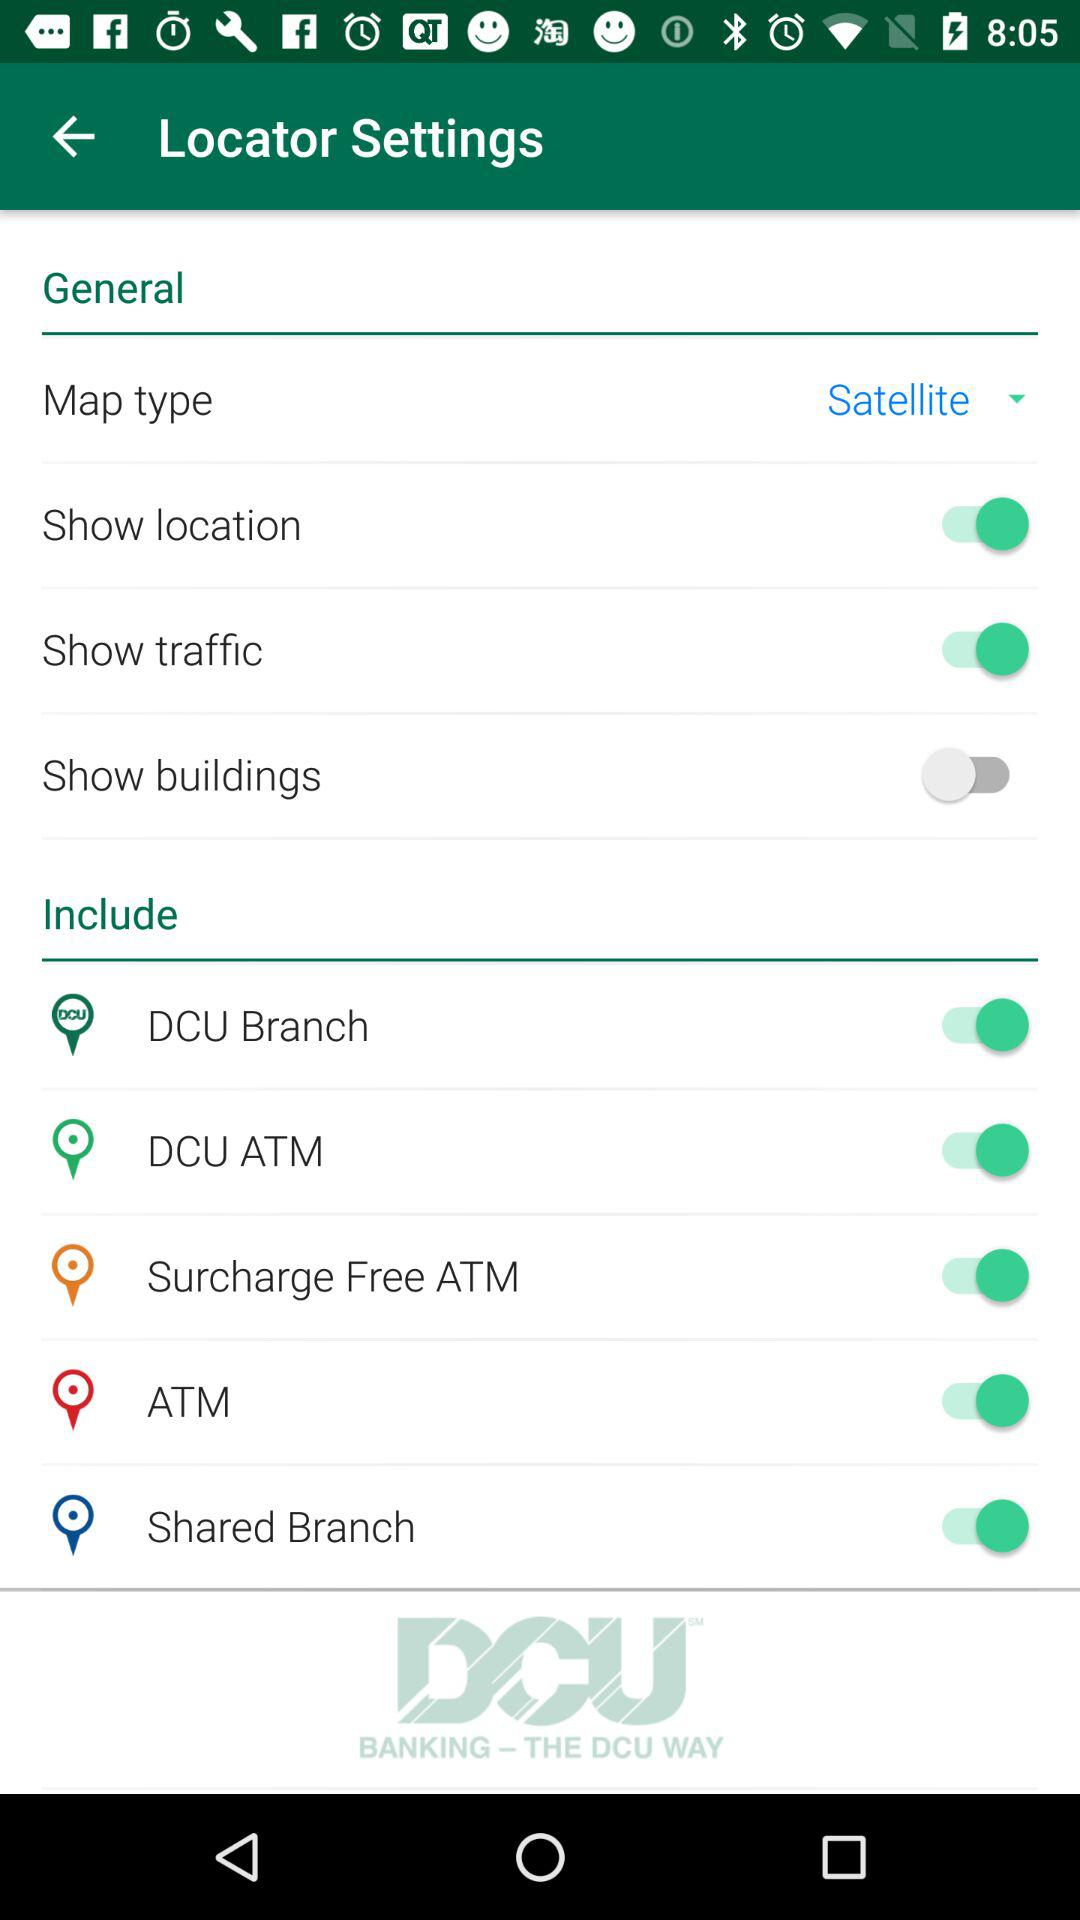What is the status of the show buildings setting? The status is off. 